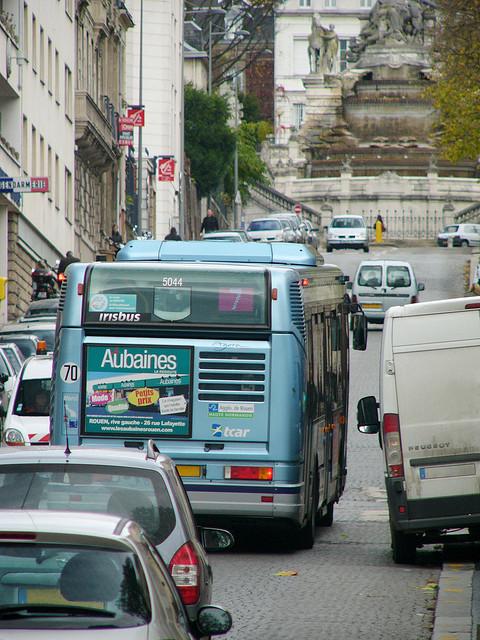What color is the van next to the bus?
Answer briefly. White. Is the street busy?
Answer briefly. Yes. What ad is on the bus?
Short answer required. Aubaines. 